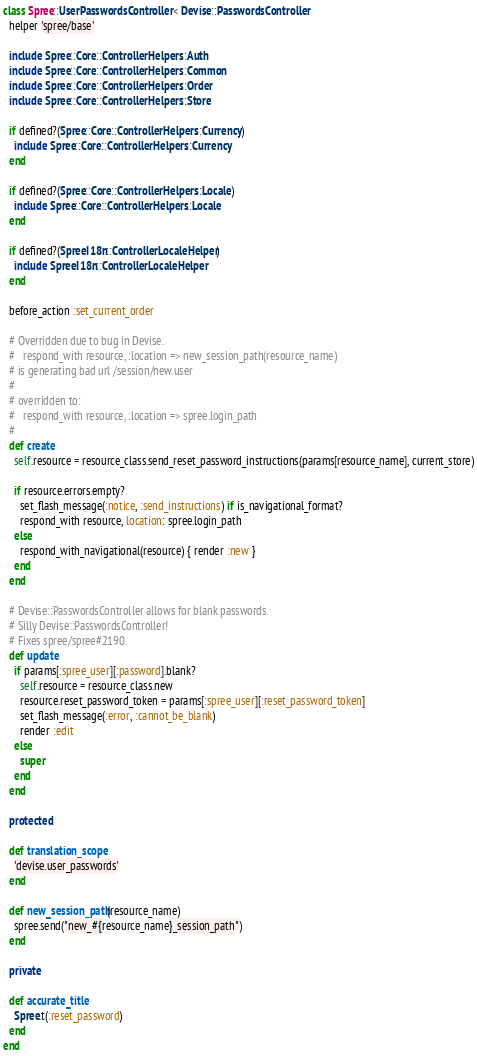<code> <loc_0><loc_0><loc_500><loc_500><_Ruby_>class Spree::UserPasswordsController < Devise::PasswordsController
  helper 'spree/base'

  include Spree::Core::ControllerHelpers::Auth
  include Spree::Core::ControllerHelpers::Common
  include Spree::Core::ControllerHelpers::Order
  include Spree::Core::ControllerHelpers::Store

  if defined?(Spree::Core::ControllerHelpers::Currency)
    include Spree::Core::ControllerHelpers::Currency
  end

  if defined?(Spree::Core::ControllerHelpers::Locale)
    include Spree::Core::ControllerHelpers::Locale
  end

  if defined?(SpreeI18n::ControllerLocaleHelper)
    include SpreeI18n::ControllerLocaleHelper
  end

  before_action :set_current_order

  # Overridden due to bug in Devise.
  #   respond_with resource, :location => new_session_path(resource_name)
  # is generating bad url /session/new.user
  #
  # overridden to:
  #   respond_with resource, :location => spree.login_path
  #
  def create
    self.resource = resource_class.send_reset_password_instructions(params[resource_name], current_store)

    if resource.errors.empty?
      set_flash_message(:notice, :send_instructions) if is_navigational_format?
      respond_with resource, location: spree.login_path
    else
      respond_with_navigational(resource) { render :new }
    end
  end

  # Devise::PasswordsController allows for blank passwords.
  # Silly Devise::PasswordsController!
  # Fixes spree/spree#2190.
  def update
    if params[:spree_user][:password].blank?
      self.resource = resource_class.new
      resource.reset_password_token = params[:spree_user][:reset_password_token]
      set_flash_message(:error, :cannot_be_blank)
      render :edit
    else
      super
    end
  end

  protected

  def translation_scope
    'devise.user_passwords'
  end

  def new_session_path(resource_name)
    spree.send("new_#{resource_name}_session_path")
  end

  private

  def accurate_title
    Spree.t(:reset_password)
  end
end
</code> 